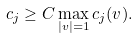Convert formula to latex. <formula><loc_0><loc_0><loc_500><loc_500>c _ { j } \geq C \max _ { | v | = 1 } c _ { j } ( v ) .</formula> 